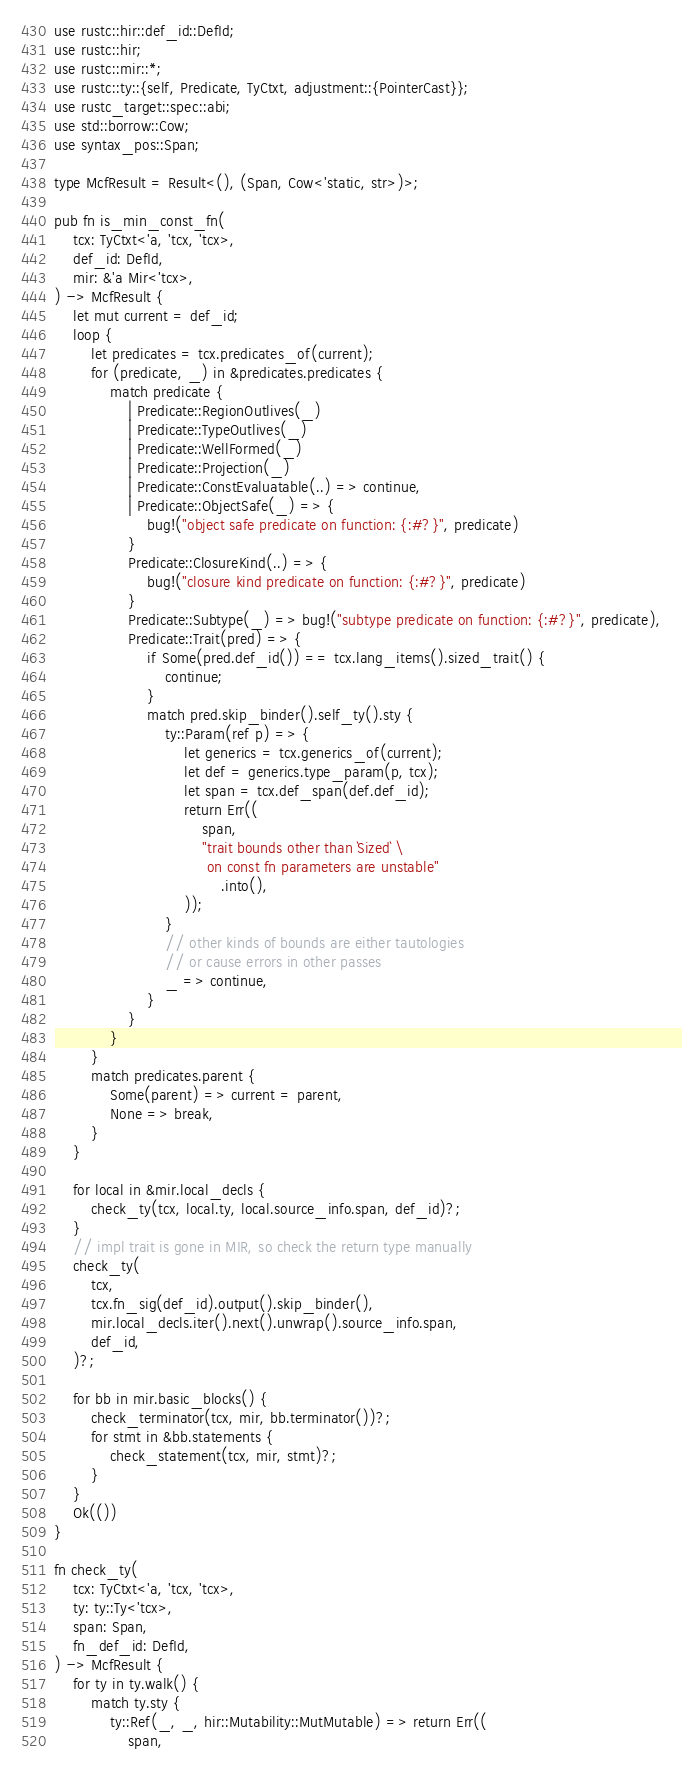<code> <loc_0><loc_0><loc_500><loc_500><_Rust_>use rustc::hir::def_id::DefId;
use rustc::hir;
use rustc::mir::*;
use rustc::ty::{self, Predicate, TyCtxt, adjustment::{PointerCast}};
use rustc_target::spec::abi;
use std::borrow::Cow;
use syntax_pos::Span;

type McfResult = Result<(), (Span, Cow<'static, str>)>;

pub fn is_min_const_fn(
    tcx: TyCtxt<'a, 'tcx, 'tcx>,
    def_id: DefId,
    mir: &'a Mir<'tcx>,
) -> McfResult {
    let mut current = def_id;
    loop {
        let predicates = tcx.predicates_of(current);
        for (predicate, _) in &predicates.predicates {
            match predicate {
                | Predicate::RegionOutlives(_)
                | Predicate::TypeOutlives(_)
                | Predicate::WellFormed(_)
                | Predicate::Projection(_)
                | Predicate::ConstEvaluatable(..) => continue,
                | Predicate::ObjectSafe(_) => {
                    bug!("object safe predicate on function: {:#?}", predicate)
                }
                Predicate::ClosureKind(..) => {
                    bug!("closure kind predicate on function: {:#?}", predicate)
                }
                Predicate::Subtype(_) => bug!("subtype predicate on function: {:#?}", predicate),
                Predicate::Trait(pred) => {
                    if Some(pred.def_id()) == tcx.lang_items().sized_trait() {
                        continue;
                    }
                    match pred.skip_binder().self_ty().sty {
                        ty::Param(ref p) => {
                            let generics = tcx.generics_of(current);
                            let def = generics.type_param(p, tcx);
                            let span = tcx.def_span(def.def_id);
                            return Err((
                                span,
                                "trait bounds other than `Sized` \
                                 on const fn parameters are unstable"
                                    .into(),
                            ));
                        }
                        // other kinds of bounds are either tautologies
                        // or cause errors in other passes
                        _ => continue,
                    }
                }
            }
        }
        match predicates.parent {
            Some(parent) => current = parent,
            None => break,
        }
    }

    for local in &mir.local_decls {
        check_ty(tcx, local.ty, local.source_info.span, def_id)?;
    }
    // impl trait is gone in MIR, so check the return type manually
    check_ty(
        tcx,
        tcx.fn_sig(def_id).output().skip_binder(),
        mir.local_decls.iter().next().unwrap().source_info.span,
        def_id,
    )?;

    for bb in mir.basic_blocks() {
        check_terminator(tcx, mir, bb.terminator())?;
        for stmt in &bb.statements {
            check_statement(tcx, mir, stmt)?;
        }
    }
    Ok(())
}

fn check_ty(
    tcx: TyCtxt<'a, 'tcx, 'tcx>,
    ty: ty::Ty<'tcx>,
    span: Span,
    fn_def_id: DefId,
) -> McfResult {
    for ty in ty.walk() {
        match ty.sty {
            ty::Ref(_, _, hir::Mutability::MutMutable) => return Err((
                span,</code> 